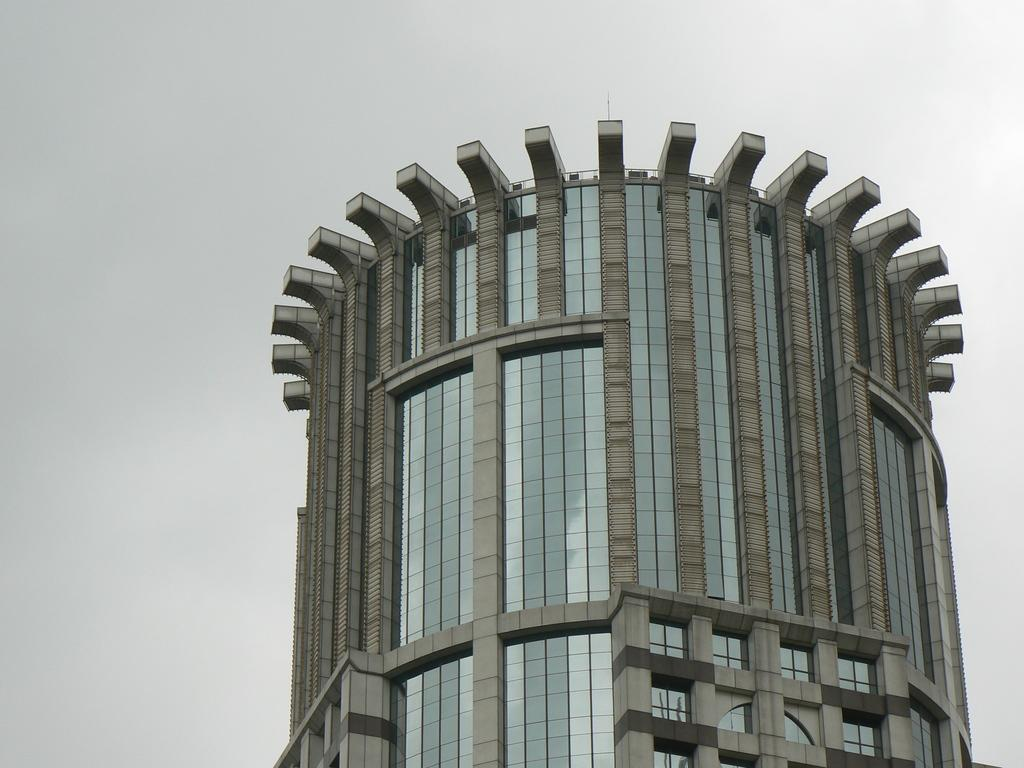What type of structure is visible in the image? There is a building in the image. What is the condition of the sky in the image? The sky is clear in the image. What type of silk material is draped over the building in the image? There is no silk material draped over the building in the image. Can you see a calculator on the building in the image? There is no calculator visible on the building in the image. 